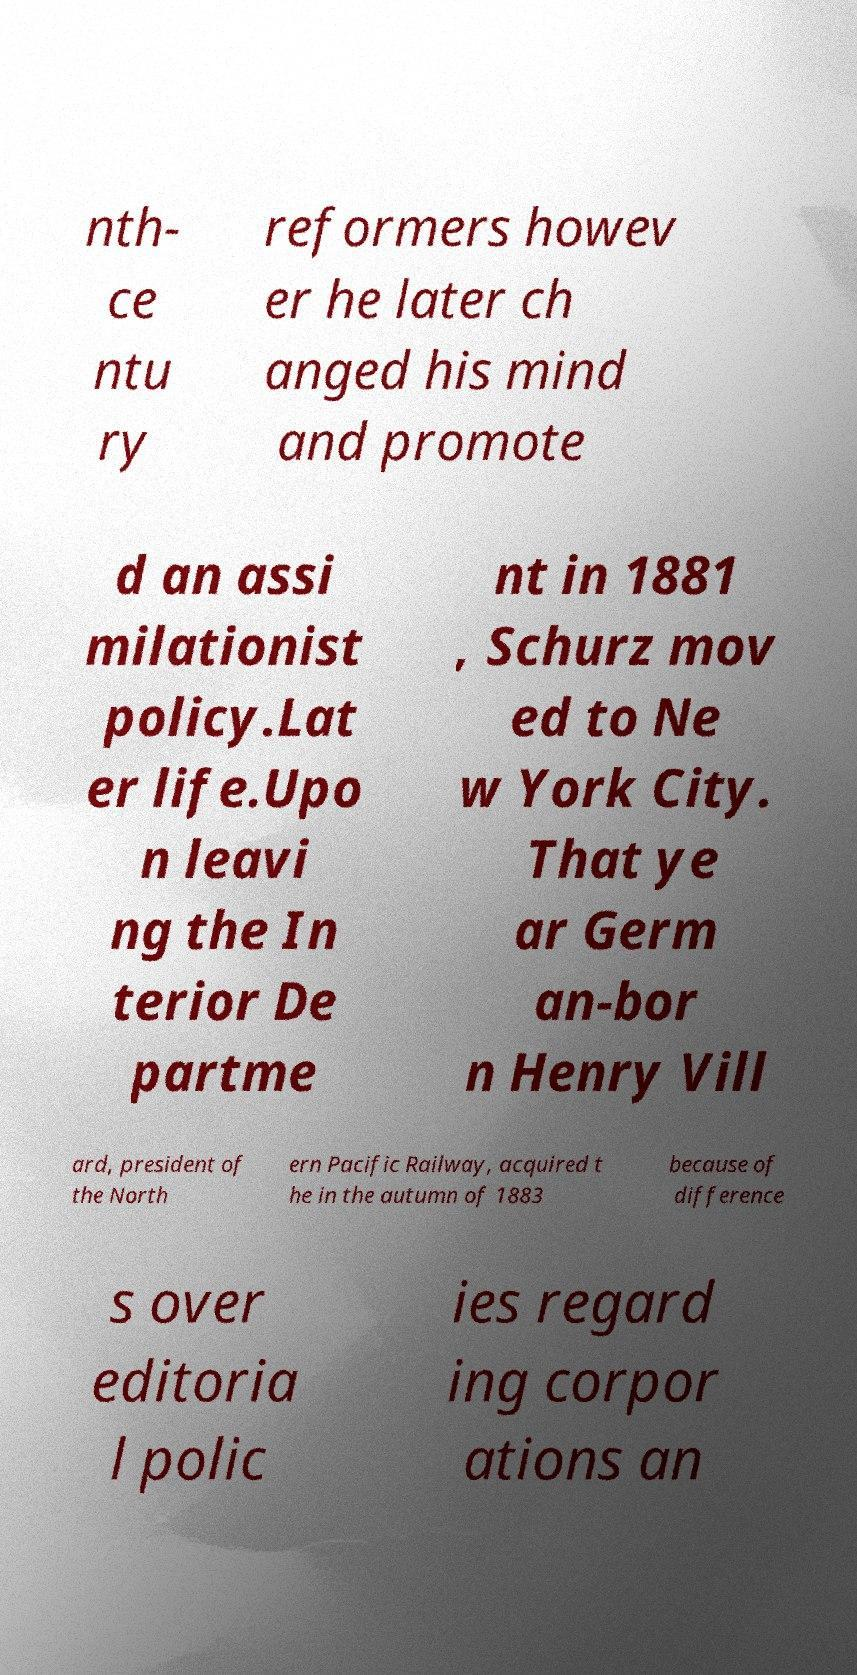Could you extract and type out the text from this image? nth- ce ntu ry reformers howev er he later ch anged his mind and promote d an assi milationist policy.Lat er life.Upo n leavi ng the In terior De partme nt in 1881 , Schurz mov ed to Ne w York City. That ye ar Germ an-bor n Henry Vill ard, president of the North ern Pacific Railway, acquired t he in the autumn of 1883 because of difference s over editoria l polic ies regard ing corpor ations an 